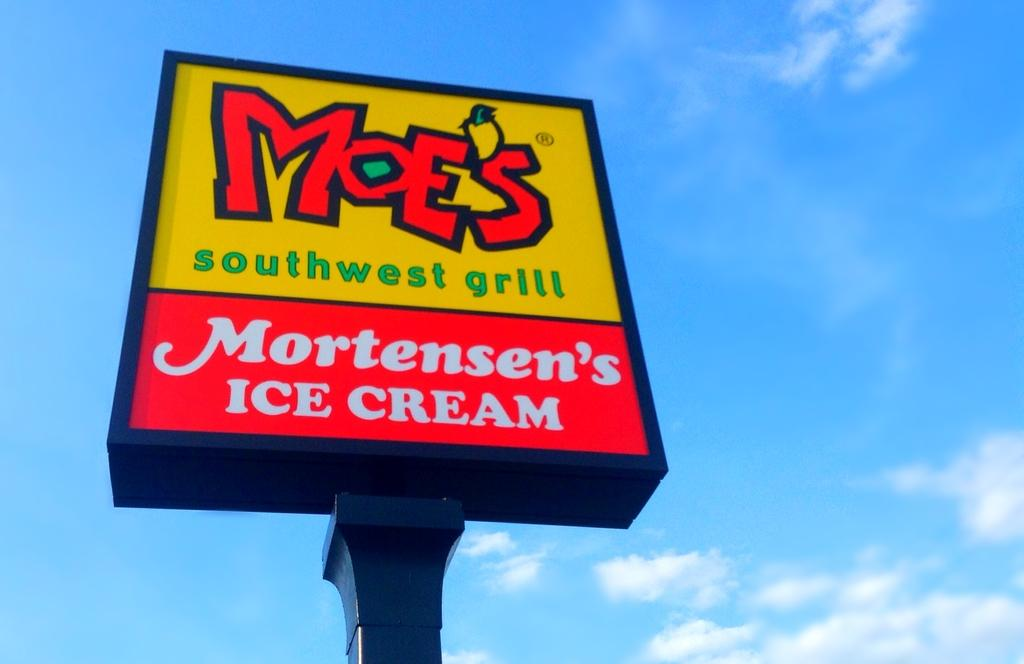Provide a one-sentence caption for the provided image. A Moes Southwest grill logo shares a sign with Mortensen's Ice Cream. 